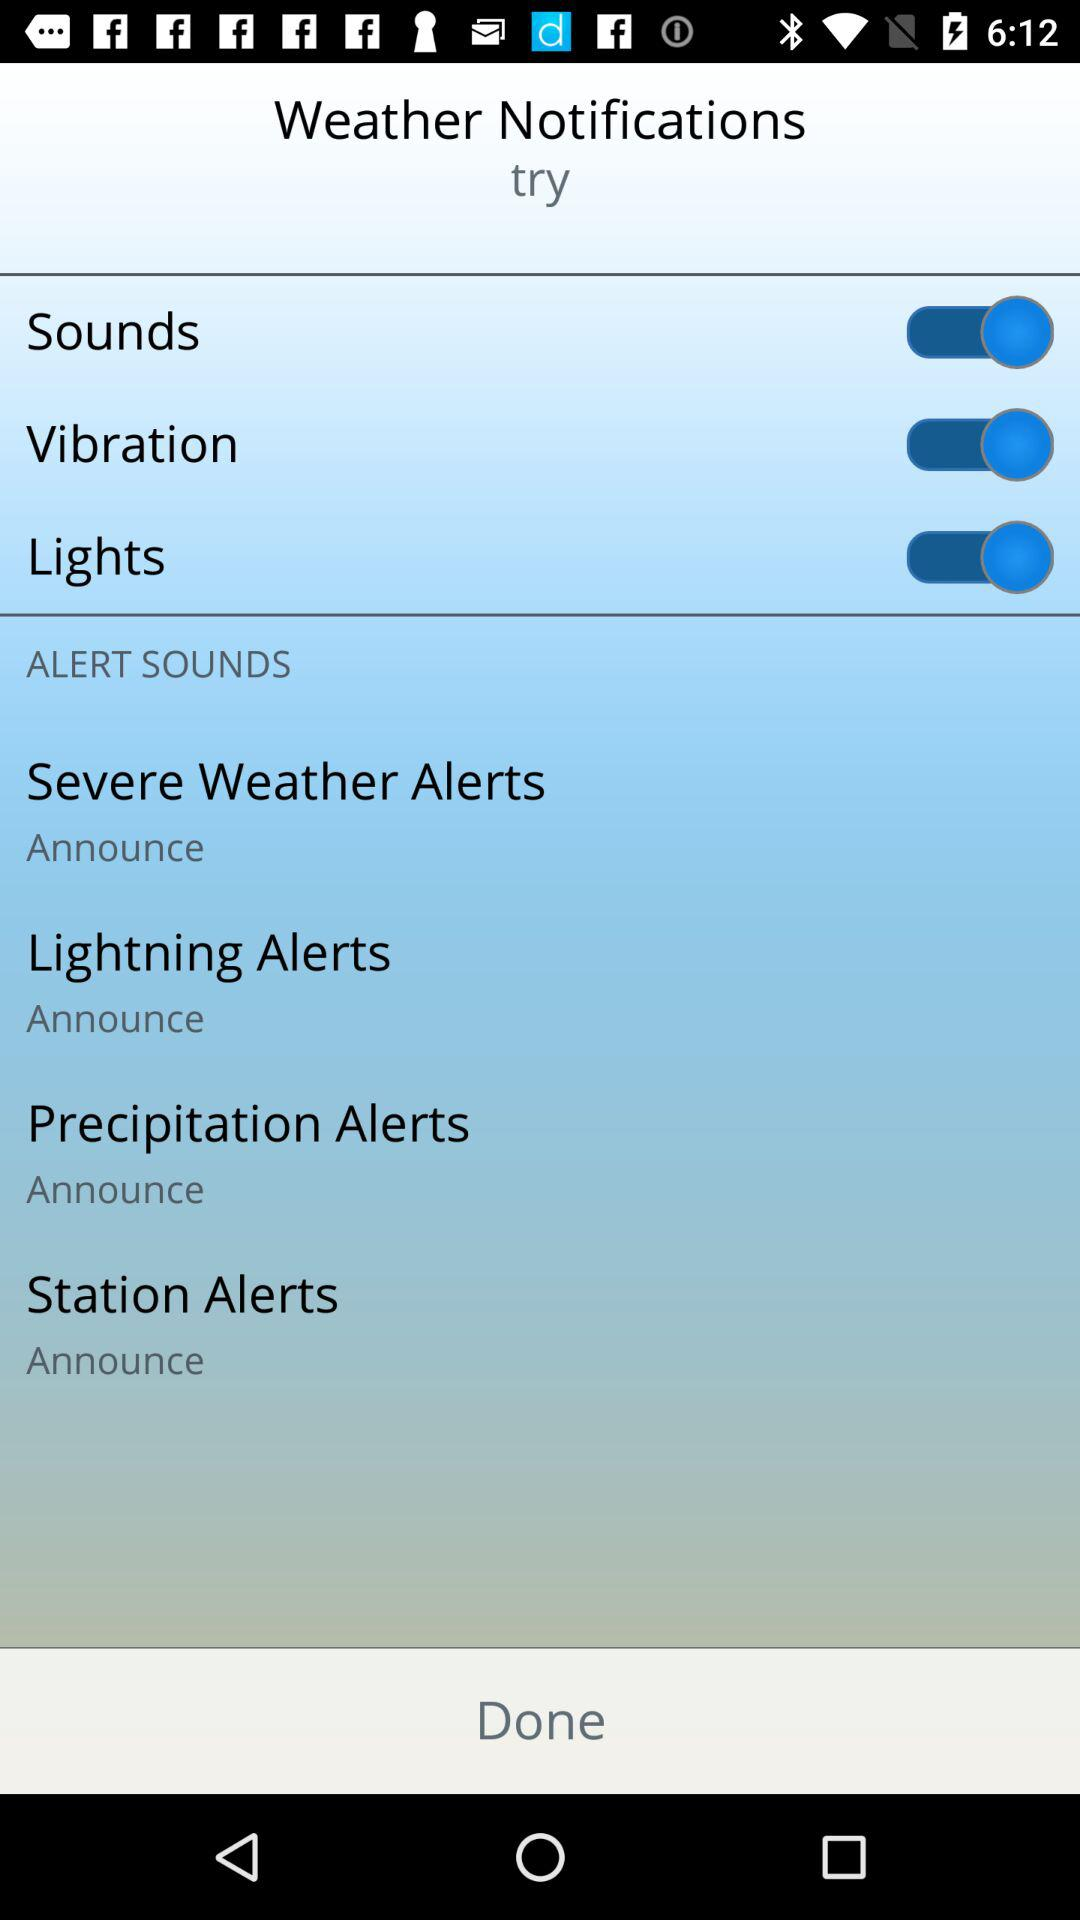What is the status of "Sounds"? The status of "Sounds" is "on". 